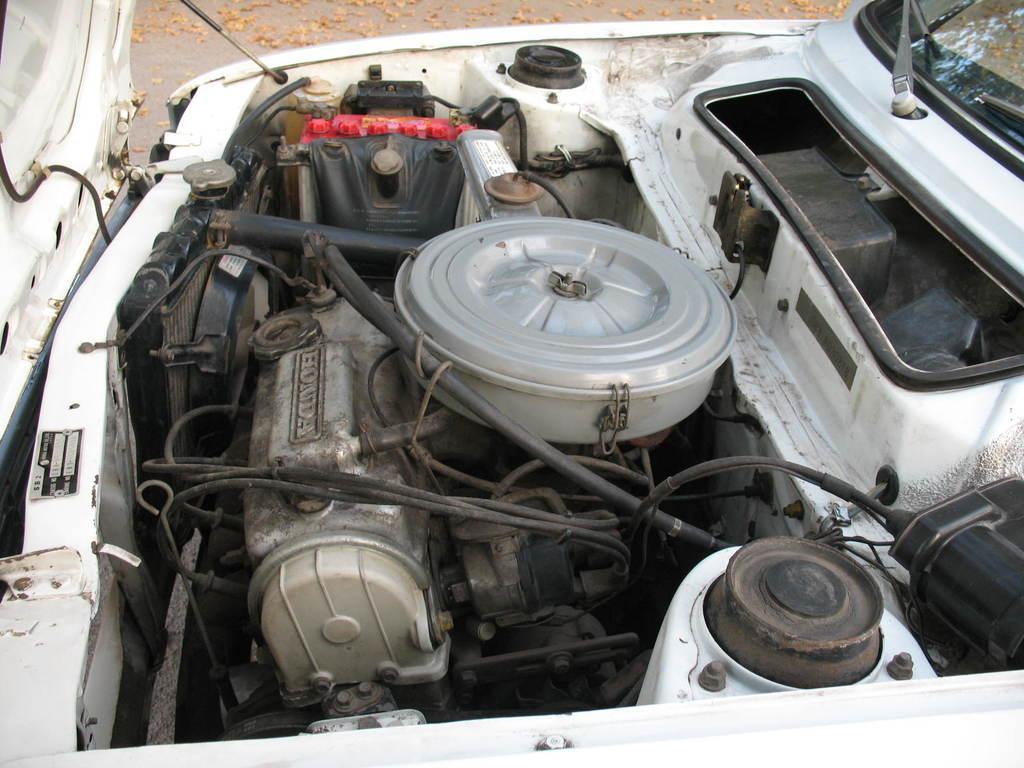Could you give a brief overview of what you see in this image? In the center of the image we can see inside parts of a car's bonnet. 